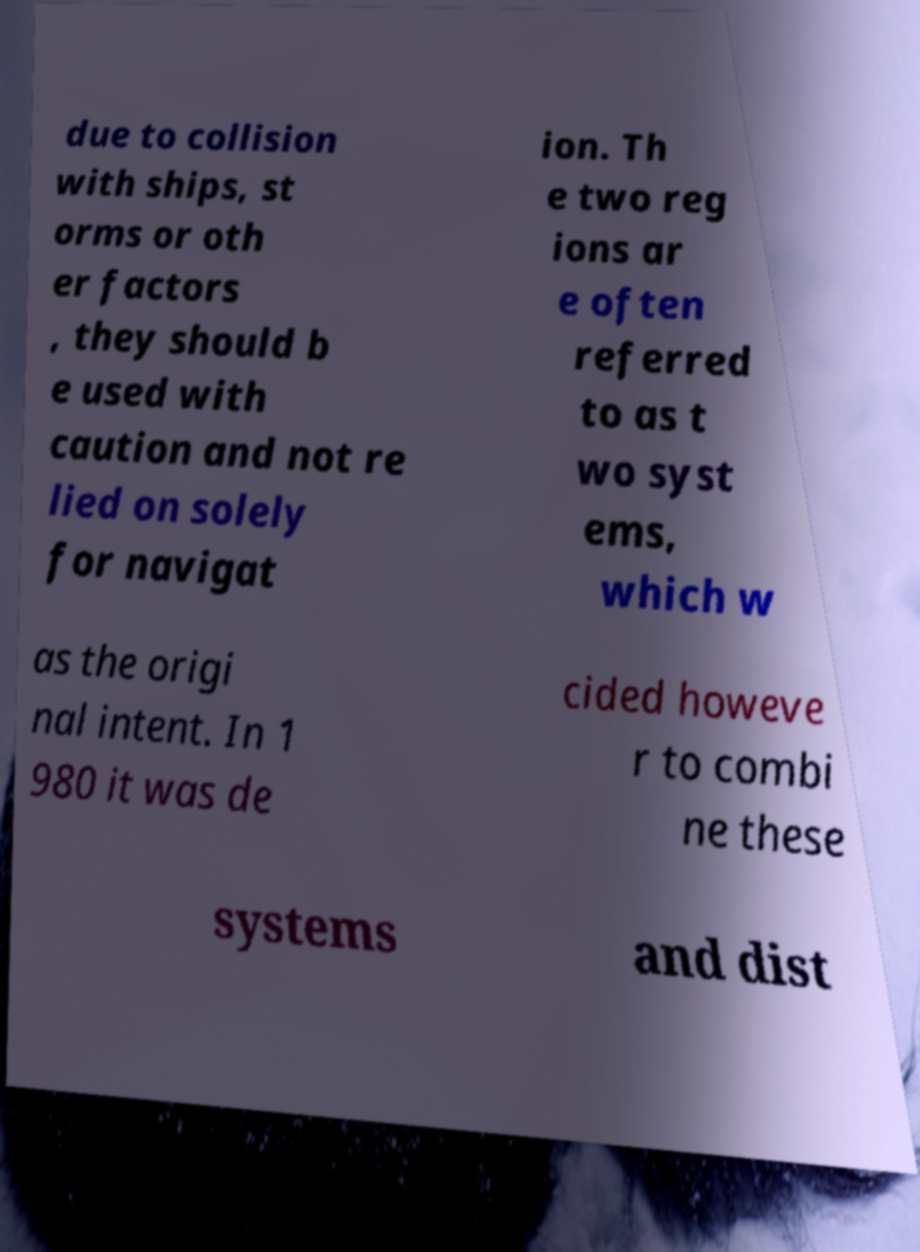Can you accurately transcribe the text from the provided image for me? due to collision with ships, st orms or oth er factors , they should b e used with caution and not re lied on solely for navigat ion. Th e two reg ions ar e often referred to as t wo syst ems, which w as the origi nal intent. In 1 980 it was de cided howeve r to combi ne these systems and dist 